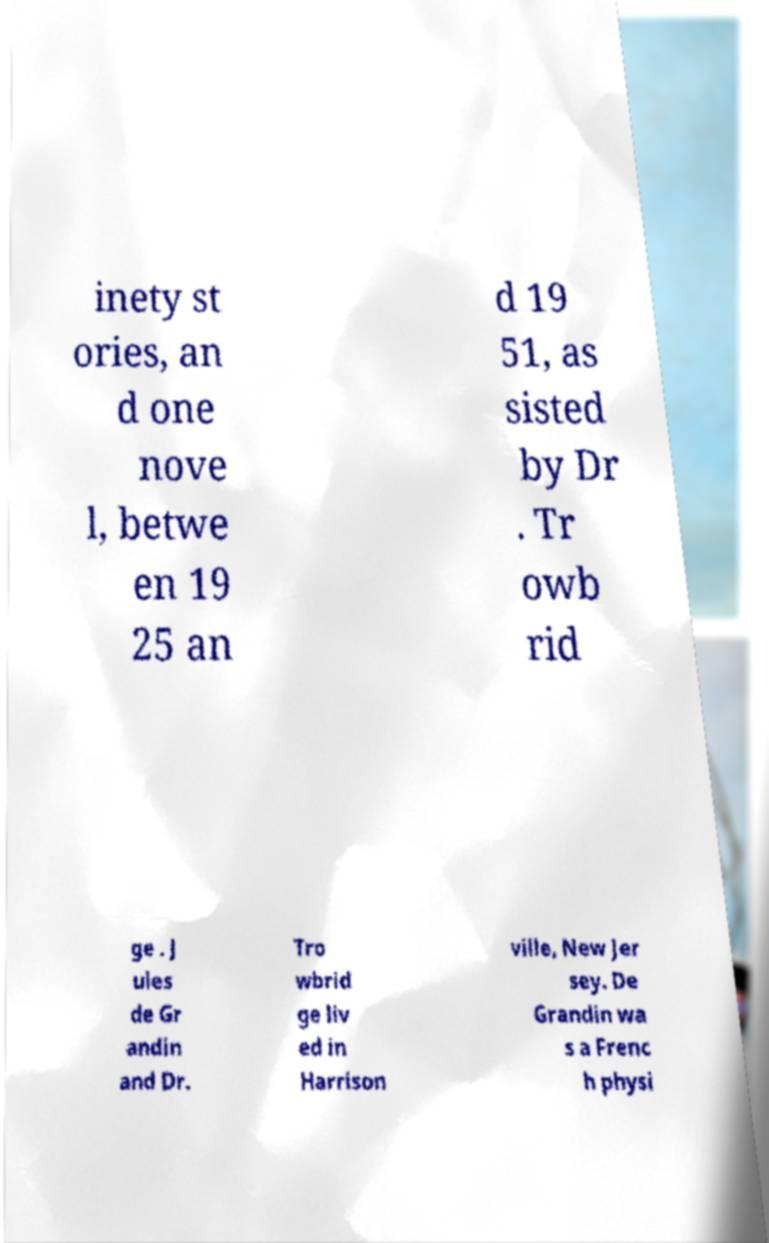Please identify and transcribe the text found in this image. inety st ories, an d one nove l, betwe en 19 25 an d 19 51, as sisted by Dr . Tr owb rid ge . J ules de Gr andin and Dr. Tro wbrid ge liv ed in Harrison ville, New Jer sey. De Grandin wa s a Frenc h physi 